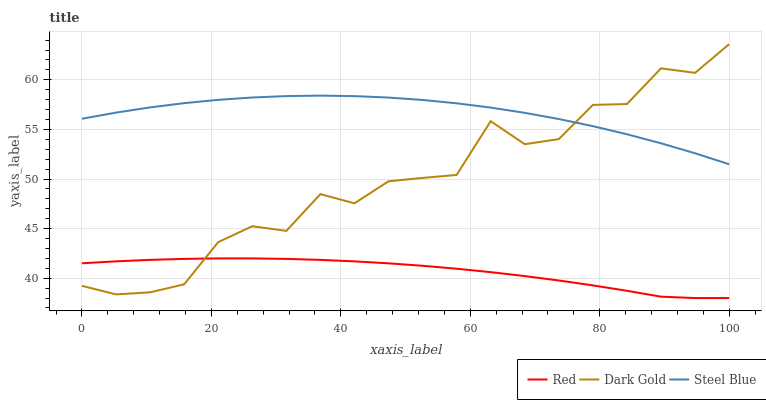Does Red have the minimum area under the curve?
Answer yes or no. Yes. Does Steel Blue have the maximum area under the curve?
Answer yes or no. Yes. Does Dark Gold have the minimum area under the curve?
Answer yes or no. No. Does Dark Gold have the maximum area under the curve?
Answer yes or no. No. Is Red the smoothest?
Answer yes or no. Yes. Is Dark Gold the roughest?
Answer yes or no. Yes. Is Dark Gold the smoothest?
Answer yes or no. No. Is Red the roughest?
Answer yes or no. No. Does Red have the lowest value?
Answer yes or no. Yes. Does Dark Gold have the lowest value?
Answer yes or no. No. Does Dark Gold have the highest value?
Answer yes or no. Yes. Does Red have the highest value?
Answer yes or no. No. Is Red less than Steel Blue?
Answer yes or no. Yes. Is Steel Blue greater than Red?
Answer yes or no. Yes. Does Steel Blue intersect Dark Gold?
Answer yes or no. Yes. Is Steel Blue less than Dark Gold?
Answer yes or no. No. Is Steel Blue greater than Dark Gold?
Answer yes or no. No. Does Red intersect Steel Blue?
Answer yes or no. No. 